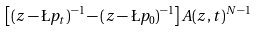<formula> <loc_0><loc_0><loc_500><loc_500>\left [ ( z - \L p _ { t } ) ^ { - 1 } - ( z - \L p _ { 0 } ) ^ { - 1 } \right ] A ( z , t ) ^ { N - 1 }</formula> 